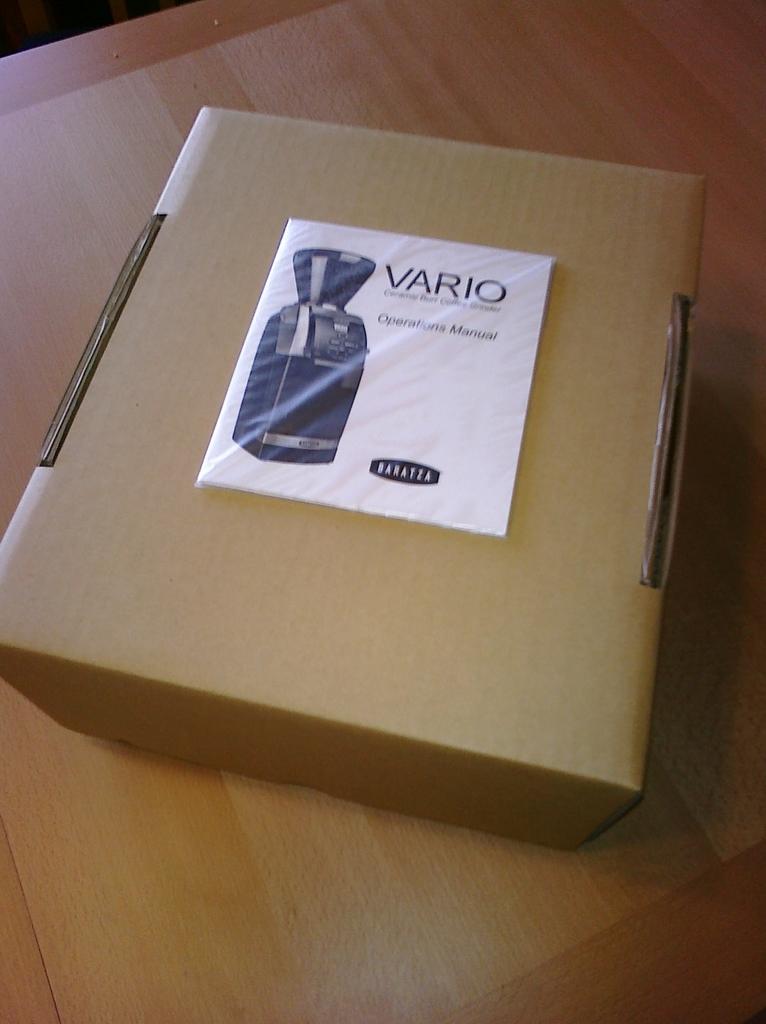What is the brand of this appliance?
Keep it short and to the point. Vario. What type of manual is attached to the box?
Your answer should be very brief. Operations manual. 